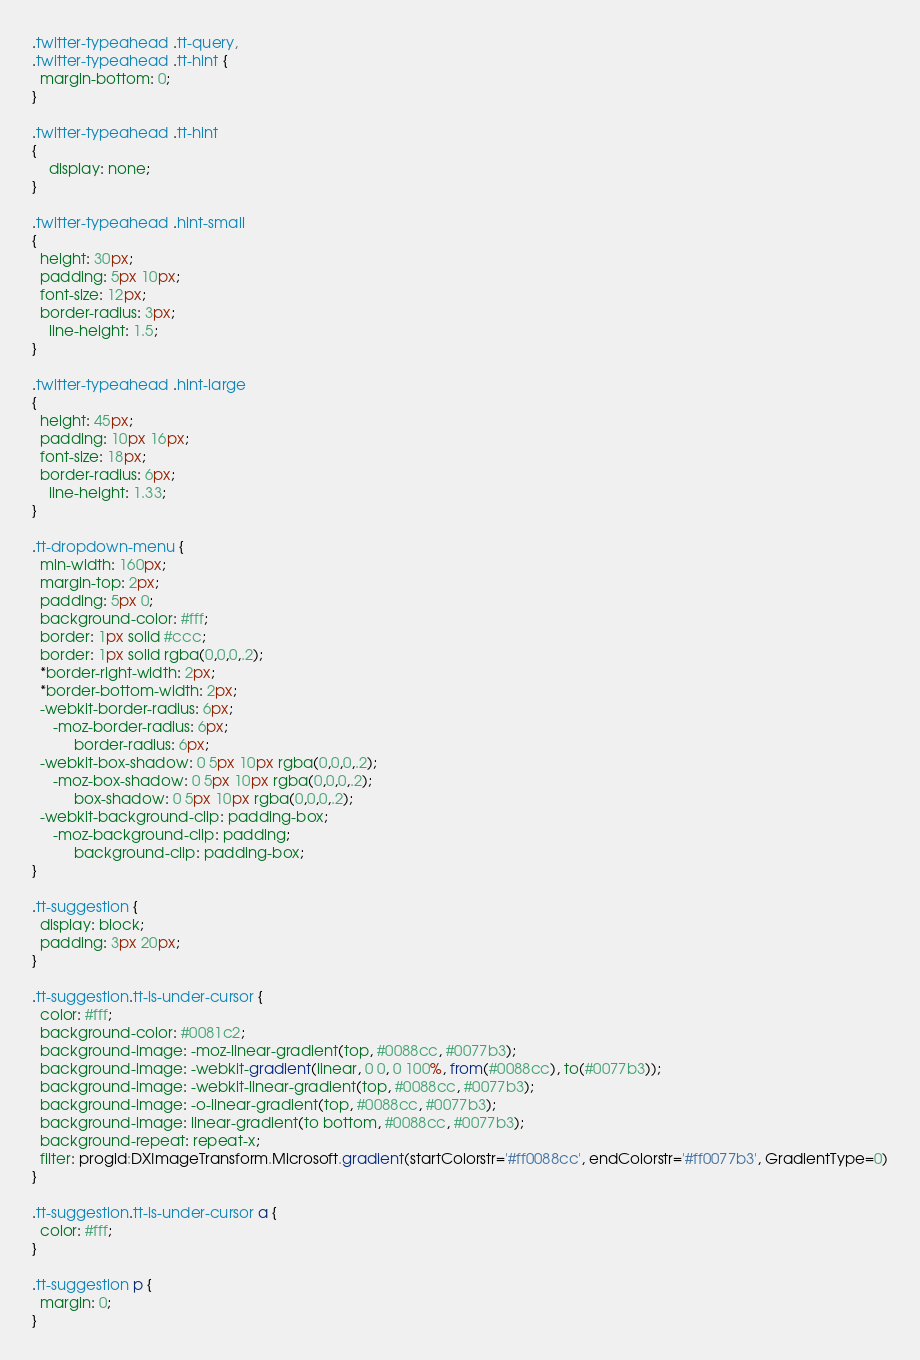<code> <loc_0><loc_0><loc_500><loc_500><_CSS_>.twitter-typeahead .tt-query,
.twitter-typeahead .tt-hint {
  margin-bottom: 0;
}

.twitter-typeahead .tt-hint
{
    display: none;
}

.twitter-typeahead .hint-small
{
  height: 30px;
  padding: 5px 10px;
  font-size: 12px;
  border-radius: 3px;
    line-height: 1.5;
}

.twitter-typeahead .hint-large
{
  height: 45px;
  padding: 10px 16px;
  font-size: 18px;
  border-radius: 6px;
    line-height: 1.33;
}

.tt-dropdown-menu {
  min-width: 160px;
  margin-top: 2px;
  padding: 5px 0;
  background-color: #fff;
  border: 1px solid #ccc;
  border: 1px solid rgba(0,0,0,.2);
  *border-right-width: 2px;
  *border-bottom-width: 2px;
  -webkit-border-radius: 6px;
     -moz-border-radius: 6px;
          border-radius: 6px;
  -webkit-box-shadow: 0 5px 10px rgba(0,0,0,.2);
     -moz-box-shadow: 0 5px 10px rgba(0,0,0,.2);
          box-shadow: 0 5px 10px rgba(0,0,0,.2);
  -webkit-background-clip: padding-box;
     -moz-background-clip: padding;
          background-clip: padding-box;
}

.tt-suggestion {
  display: block;
  padding: 3px 20px;
}

.tt-suggestion.tt-is-under-cursor {
  color: #fff;
  background-color: #0081c2;
  background-image: -moz-linear-gradient(top, #0088cc, #0077b3);
  background-image: -webkit-gradient(linear, 0 0, 0 100%, from(#0088cc), to(#0077b3));
  background-image: -webkit-linear-gradient(top, #0088cc, #0077b3);
  background-image: -o-linear-gradient(top, #0088cc, #0077b3);
  background-image: linear-gradient(to bottom, #0088cc, #0077b3);
  background-repeat: repeat-x;
  filter: progid:DXImageTransform.Microsoft.gradient(startColorstr='#ff0088cc', endColorstr='#ff0077b3', GradientType=0)
}

.tt-suggestion.tt-is-under-cursor a {
  color: #fff;
}

.tt-suggestion p {
  margin: 0;
}
</code> 